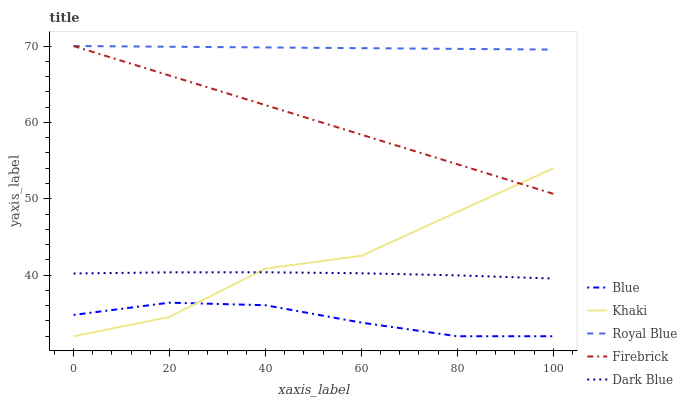Does Blue have the minimum area under the curve?
Answer yes or no. Yes. Does Royal Blue have the maximum area under the curve?
Answer yes or no. Yes. Does Firebrick have the minimum area under the curve?
Answer yes or no. No. Does Firebrick have the maximum area under the curve?
Answer yes or no. No. Is Firebrick the smoothest?
Answer yes or no. Yes. Is Khaki the roughest?
Answer yes or no. Yes. Is Royal Blue the smoothest?
Answer yes or no. No. Is Royal Blue the roughest?
Answer yes or no. No. Does Blue have the lowest value?
Answer yes or no. Yes. Does Firebrick have the lowest value?
Answer yes or no. No. Does Firebrick have the highest value?
Answer yes or no. Yes. Does Khaki have the highest value?
Answer yes or no. No. Is Dark Blue less than Firebrick?
Answer yes or no. Yes. Is Firebrick greater than Blue?
Answer yes or no. Yes. Does Blue intersect Khaki?
Answer yes or no. Yes. Is Blue less than Khaki?
Answer yes or no. No. Is Blue greater than Khaki?
Answer yes or no. No. Does Dark Blue intersect Firebrick?
Answer yes or no. No. 